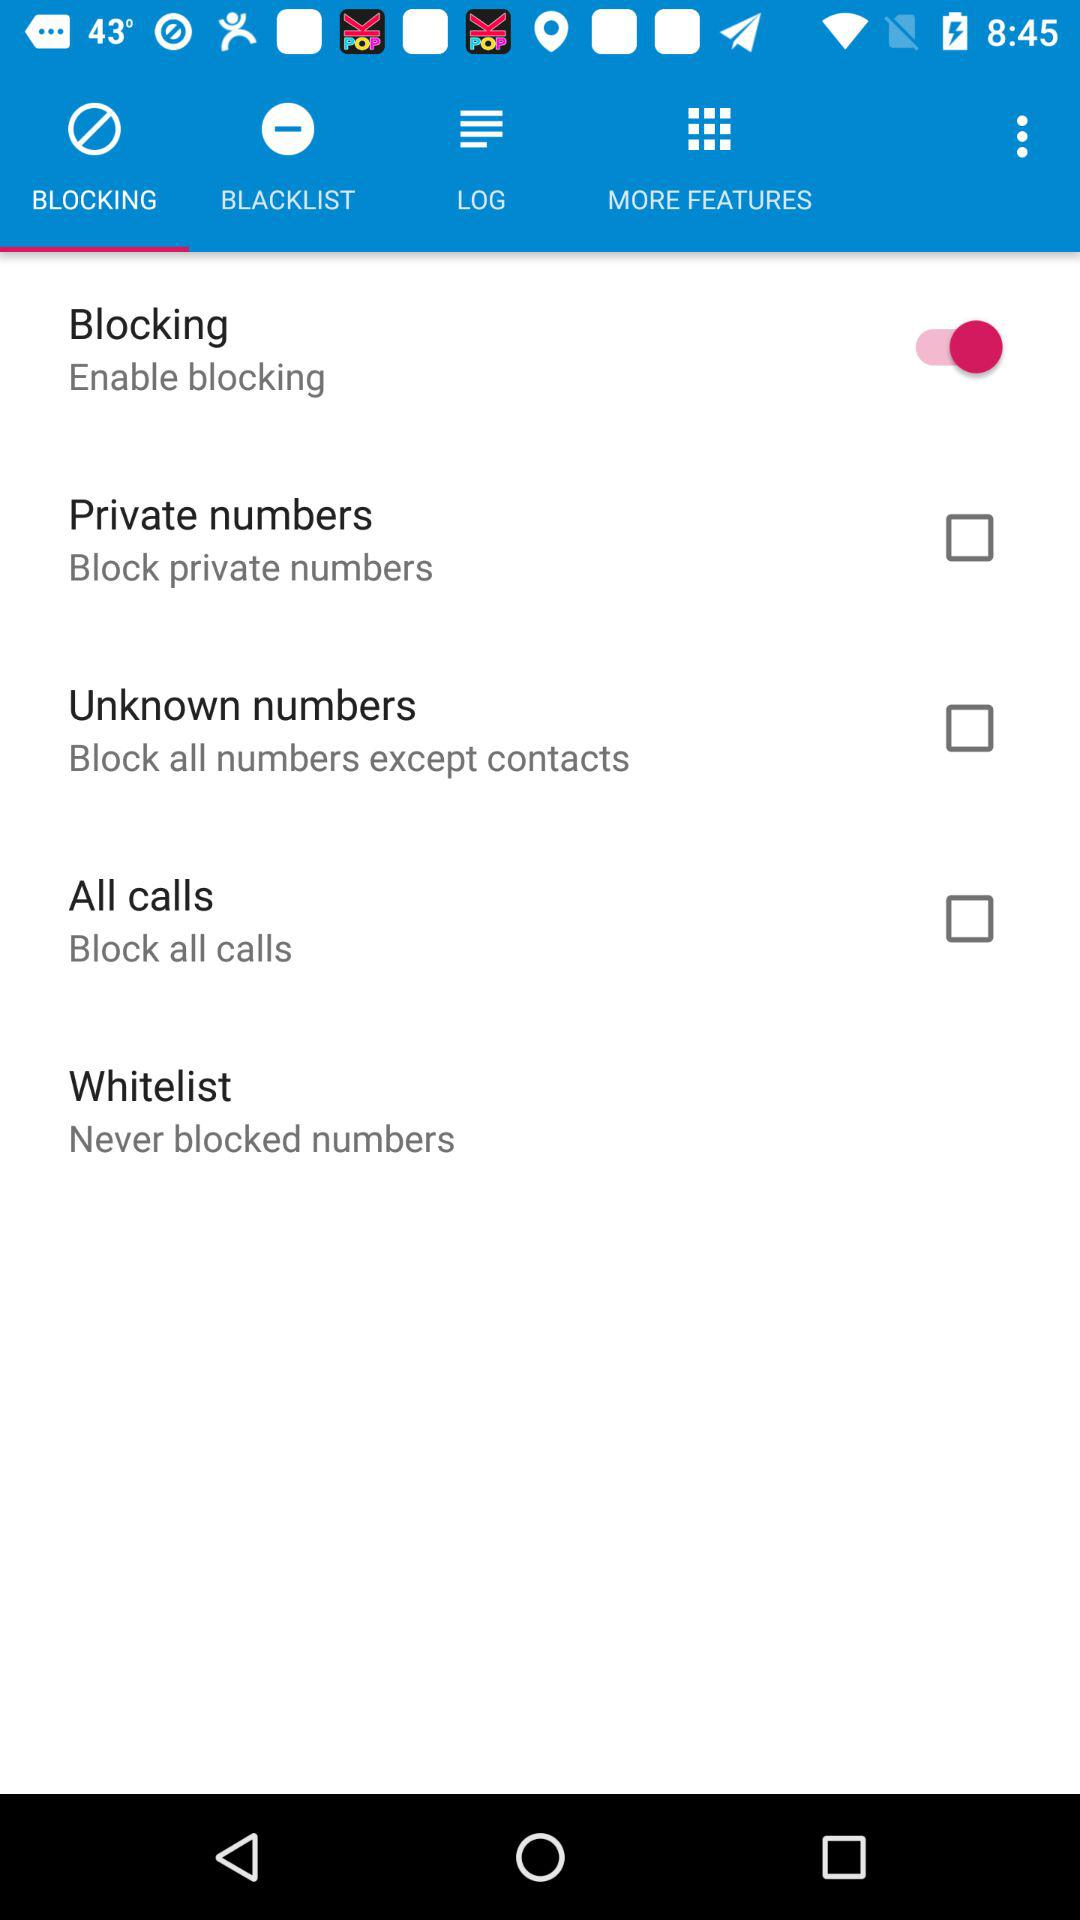Which tab is selected? The selected tab is "BLOCKING". 